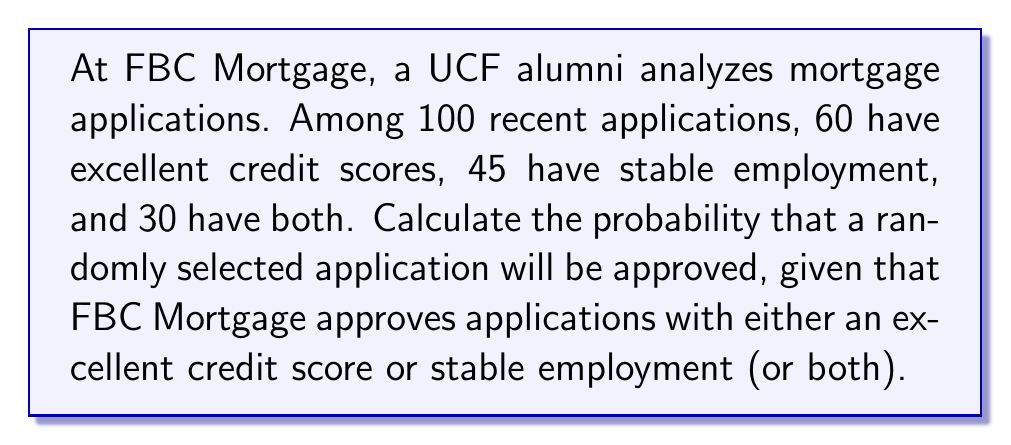Help me with this question. Let's approach this problem using set theory:

1) Define our sets:
   $A$: applications with excellent credit scores
   $B$: applications with stable employment

2) Given information:
   $|U| = 100$ (total applications)
   $|A| = 60$
   $|B| = 45$
   $|A \cap B| = 30$

3) We need to find $P(A \cup B)$, as an application is approved if it's in either set A or B (or both).

4) Using the inclusion-exclusion principle:
   $$|A \cup B| = |A| + |B| - |A \cap B|$$

5) Substituting our values:
   $$|A \cup B| = 60 + 45 - 30 = 75$$

6) The probability is then:
   $$P(A \cup B) = \frac{|A \cup B|}{|U|} = \frac{75}{100} = 0.75$$

This result aligns with FBC Mortgage's approval criteria, as 75% of applications meet their standards, reflecting the company's commitment to responsible lending while maintaining a competitive edge in the mortgage industry.
Answer: $0.75$ or $75\%$ 